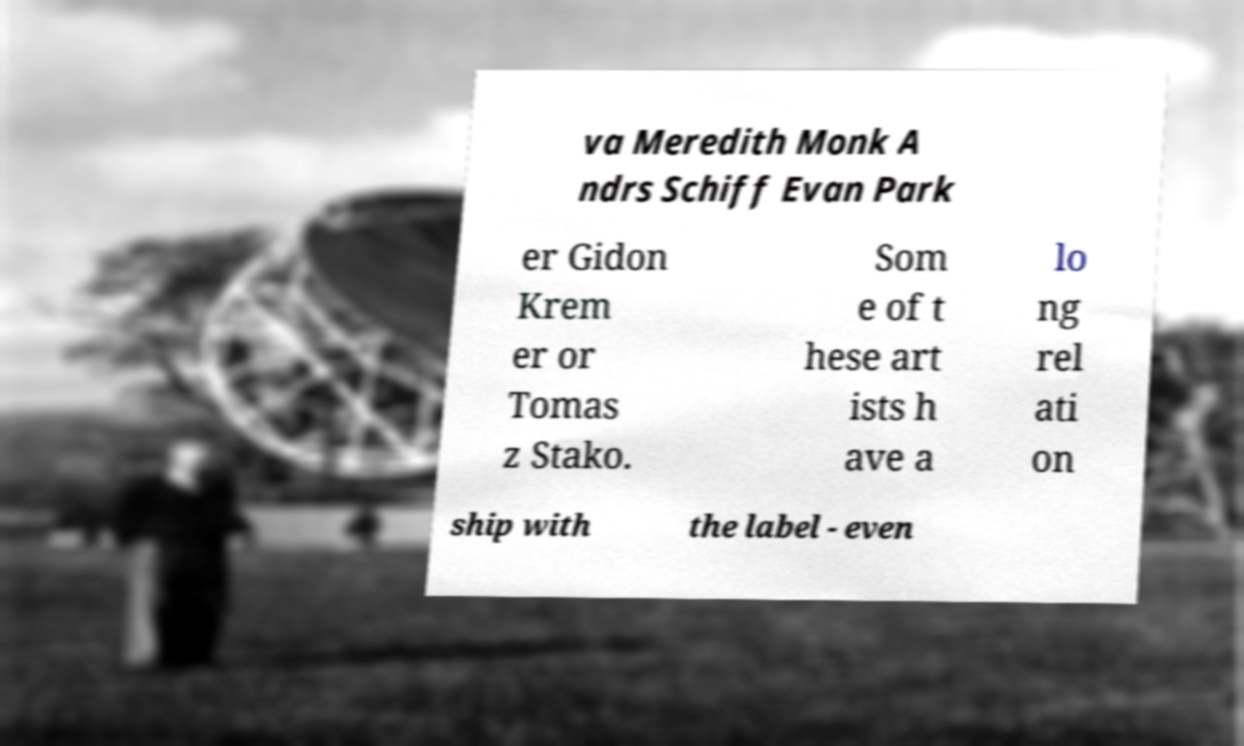Please identify and transcribe the text found in this image. va Meredith Monk A ndrs Schiff Evan Park er Gidon Krem er or Tomas z Stako. Som e of t hese art ists h ave a lo ng rel ati on ship with the label - even 